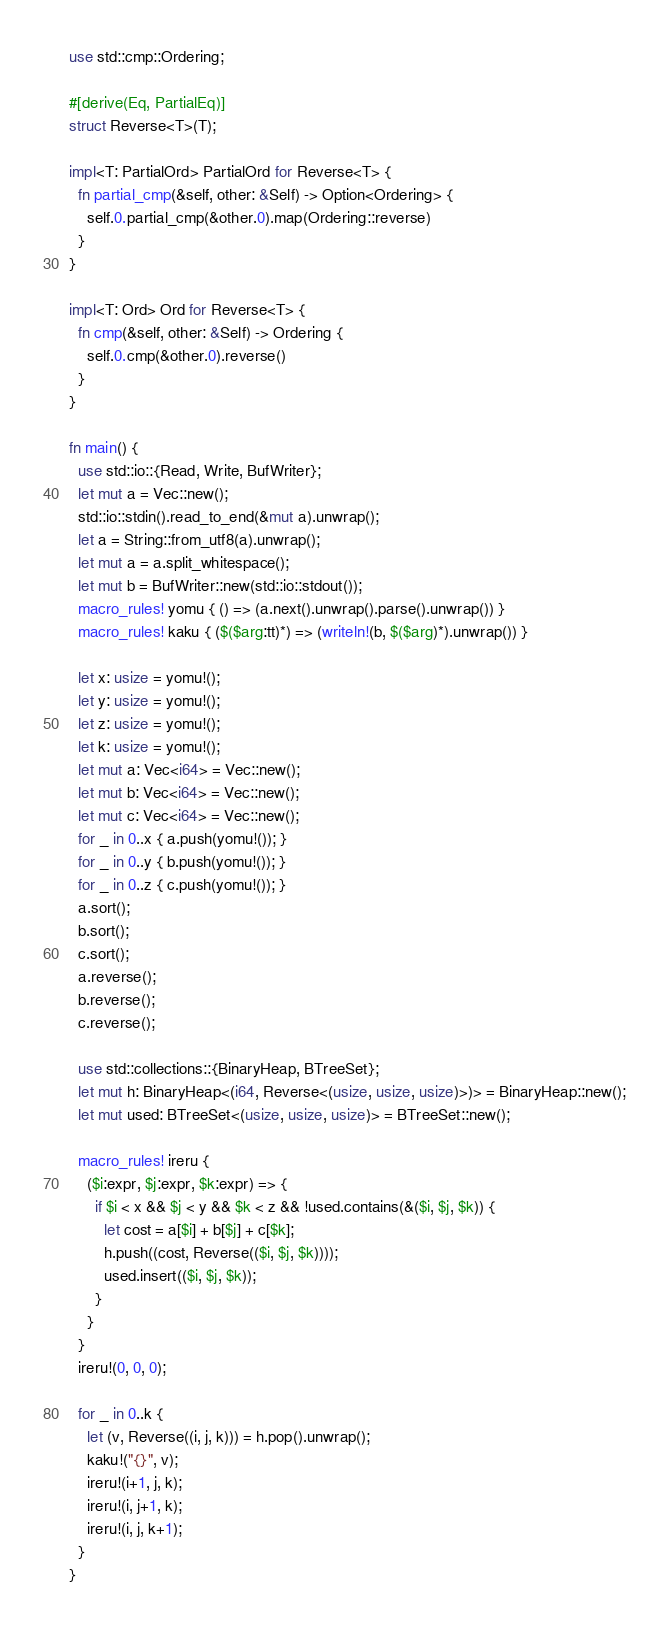Convert code to text. <code><loc_0><loc_0><loc_500><loc_500><_Rust_>use std::cmp::Ordering;

#[derive(Eq, PartialEq)]
struct Reverse<T>(T);

impl<T: PartialOrd> PartialOrd for Reverse<T> {
  fn partial_cmp(&self, other: &Self) -> Option<Ordering> {
    self.0.partial_cmp(&other.0).map(Ordering::reverse)
  }
}

impl<T: Ord> Ord for Reverse<T> {
  fn cmp(&self, other: &Self) -> Ordering {
    self.0.cmp(&other.0).reverse()
  }
}

fn main() {
  use std::io::{Read, Write, BufWriter};
  let mut a = Vec::new();
  std::io::stdin().read_to_end(&mut a).unwrap();
  let a = String::from_utf8(a).unwrap();
  let mut a = a.split_whitespace();
  let mut b = BufWriter::new(std::io::stdout());
  macro_rules! yomu { () => (a.next().unwrap().parse().unwrap()) }
  macro_rules! kaku { ($($arg:tt)*) => (writeln!(b, $($arg)*).unwrap()) }

  let x: usize = yomu!();
  let y: usize = yomu!();
  let z: usize = yomu!();
  let k: usize = yomu!();
  let mut a: Vec<i64> = Vec::new();
  let mut b: Vec<i64> = Vec::new();
  let mut c: Vec<i64> = Vec::new();
  for _ in 0..x { a.push(yomu!()); }
  for _ in 0..y { b.push(yomu!()); }
  for _ in 0..z { c.push(yomu!()); }
  a.sort();
  b.sort();
  c.sort();
  a.reverse();
  b.reverse();
  c.reverse();

  use std::collections::{BinaryHeap, BTreeSet};
  let mut h: BinaryHeap<(i64, Reverse<(usize, usize, usize)>)> = BinaryHeap::new();
  let mut used: BTreeSet<(usize, usize, usize)> = BTreeSet::new();

  macro_rules! ireru {
    ($i:expr, $j:expr, $k:expr) => {
      if $i < x && $j < y && $k < z && !used.contains(&($i, $j, $k)) {
        let cost = a[$i] + b[$j] + c[$k];
        h.push((cost, Reverse(($i, $j, $k))));
        used.insert(($i, $j, $k));
      }
    }
  }
  ireru!(0, 0, 0);

  for _ in 0..k {
    let (v, Reverse((i, j, k))) = h.pop().unwrap();
    kaku!("{}", v);
    ireru!(i+1, j, k);
    ireru!(i, j+1, k);
    ireru!(i, j, k+1);
  }
}
</code> 